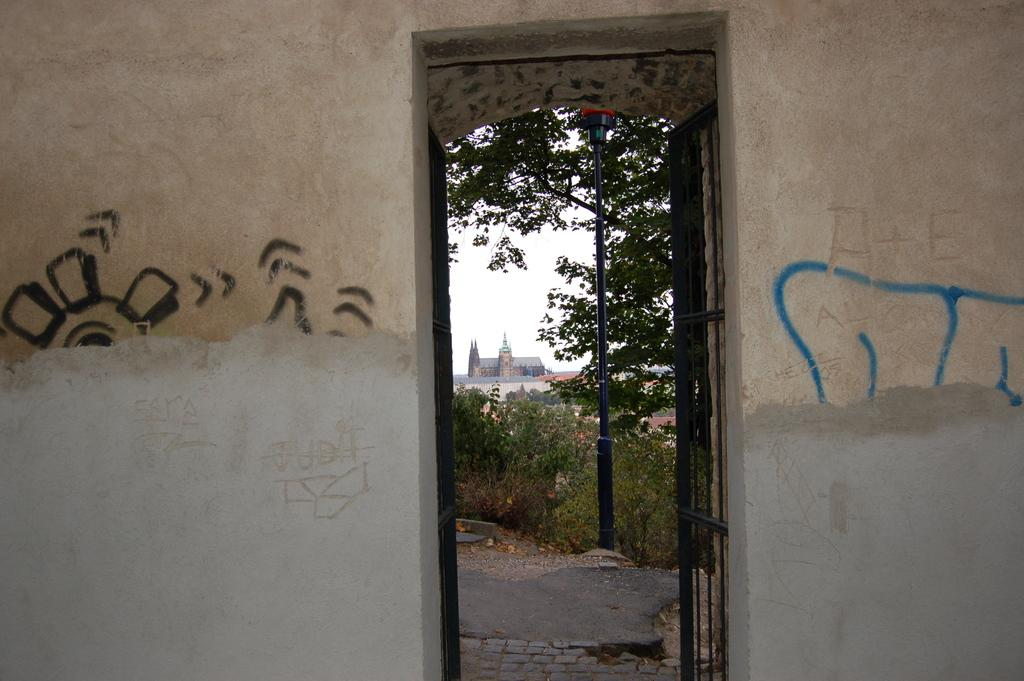What type of structure can be seen in the image? There is a door and a wall visible in the image. What type of vegetation is present in the image? There are plants and trees visible in the image. What other objects can be seen in the image? There is a pole, a building, and the sky is clear. What type of bottle can be seen rubbing against the tree in the image? There is no bottle or tree rubbing against each other in the image. 